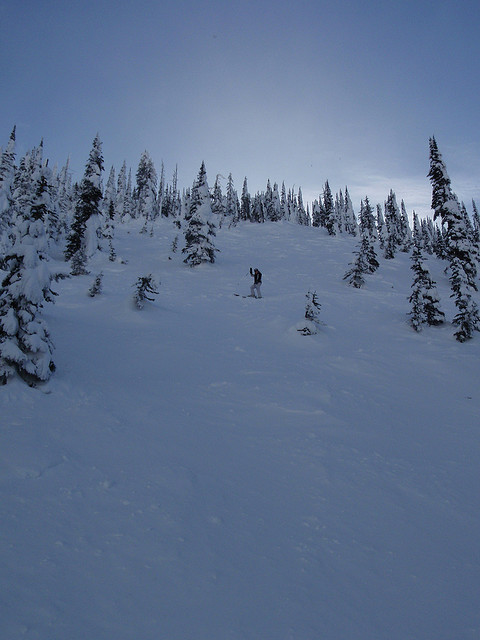What details can be observed about the mountain in the image? The mountain depicted in the image showcases a vast, inviting terrain blanketed in snow, ideal for winter sports. It's a serene yet exhilarating landscape, bustling with the activity of snowboarders and skiers, and surrounded by a forest of snow-draped pines and firs that add to the location's allure. 